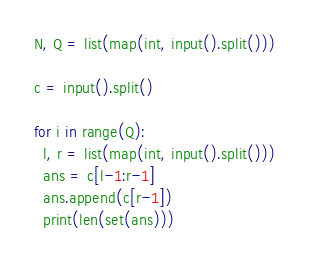<code> <loc_0><loc_0><loc_500><loc_500><_Python_>N, Q = list(map(int, input().split()))

c = input().split()
  
for i in range(Q):
  l, r = list(map(int, input().split()))
  ans = c[l-1:r-1]
  ans.append(c[r-1])
  print(len(set(ans)))</code> 